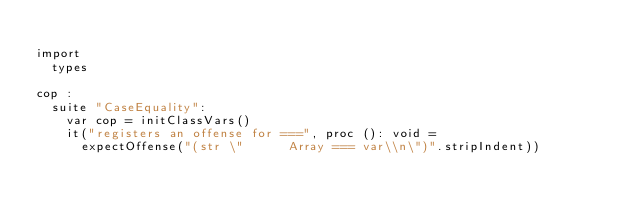Convert code to text. <code><loc_0><loc_0><loc_500><loc_500><_Nim_>
import
  types

cop :
  suite "CaseEquality":
    var cop = initClassVars()
    it("registers an offense for ===", proc (): void =
      expectOffense("(str \"      Array === var\\n\")".stripIndent))
</code> 